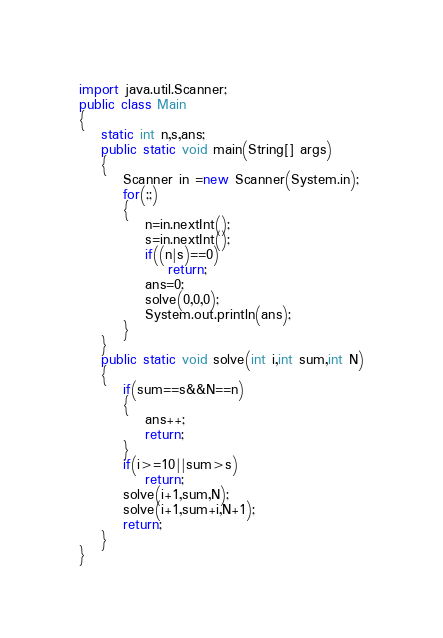Convert code to text. <code><loc_0><loc_0><loc_500><loc_500><_Java_>import java.util.Scanner;
public class Main
{
	static int n,s,ans;
	public static void main(String[] args) 
	{
		Scanner in =new Scanner(System.in);
		for(;;)
		{
			n=in.nextInt();
			s=in.nextInt();
			if((n|s)==0)
				return;
			ans=0;
			solve(0,0,0);
			System.out.println(ans);
		}
	}
	public static void solve(int i,int sum,int N)
	{
		if(sum==s&&N==n)
		{
			ans++;
			return;
		}
		if(i>=10||sum>s)
			return;
		solve(i+1,sum,N);
		solve(i+1,sum+i,N+1);
		return;
	}
}</code> 